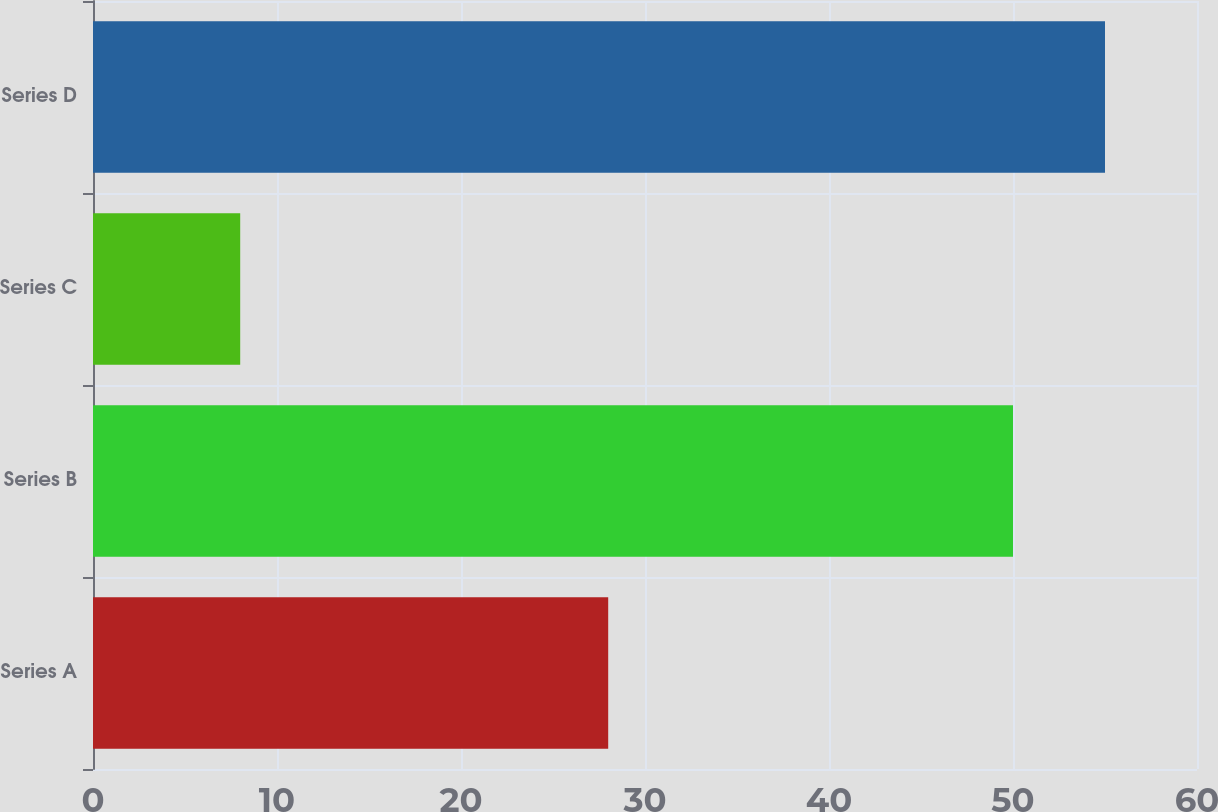Convert chart to OTSL. <chart><loc_0><loc_0><loc_500><loc_500><bar_chart><fcel>Series A<fcel>Series B<fcel>Series C<fcel>Series D<nl><fcel>28<fcel>50<fcel>8<fcel>55<nl></chart> 